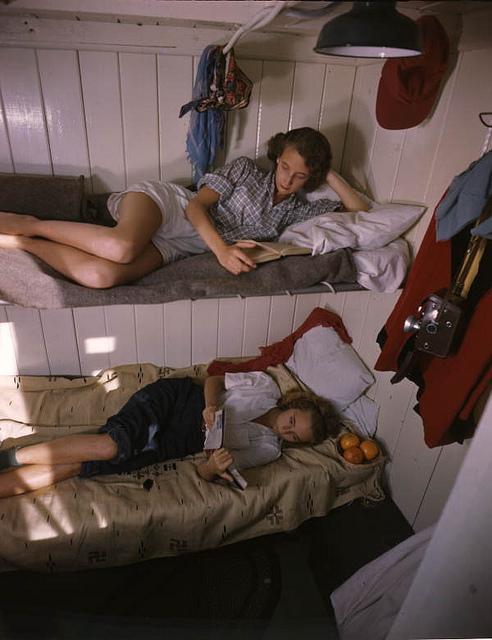How many people are in this picture?
Give a very brief answer. 2. How many beds are there?
Give a very brief answer. 2. How many people can be seen?
Give a very brief answer. 2. 